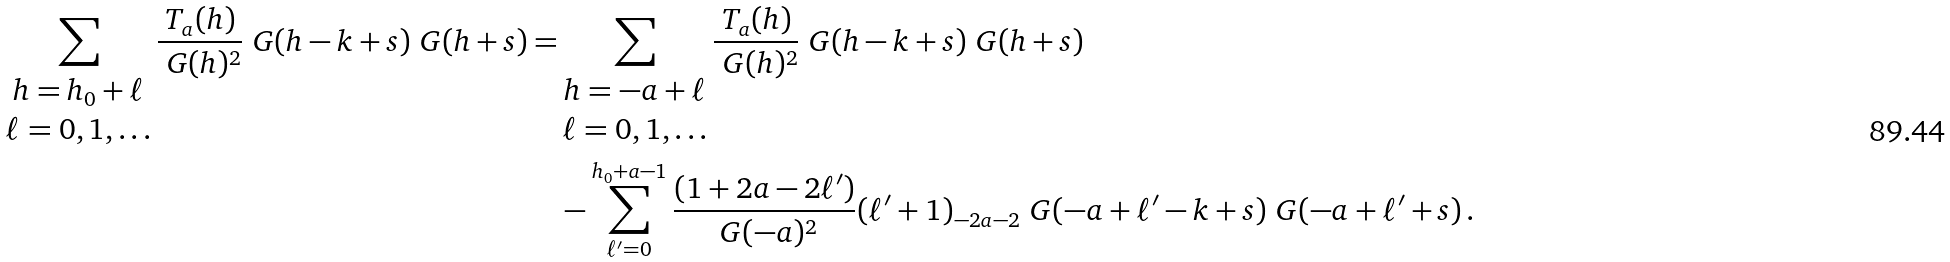Convert formula to latex. <formula><loc_0><loc_0><loc_500><loc_500>\sum _ { \begin{matrix} h = h _ { 0 } + \ell \\ \ell = 0 , 1 , \dots \end{matrix} } \frac { T _ { a } ( h ) } { \ G ( h ) ^ { 2 } } \ G ( h - k + s ) \ G ( h + s ) = & \sum _ { \begin{matrix} h = - a + \ell \\ \ell = 0 , 1 , \dots \end{matrix} } \frac { T _ { a } ( h ) } { \ G ( h ) ^ { 2 } } \ G ( h - k + s ) \ G ( h + s ) \\ & - \sum _ { \ell ^ { \prime } = 0 } ^ { h _ { 0 } + a - 1 } \frac { ( 1 + 2 a - 2 \ell ^ { \prime } ) } { \ G ( - a ) ^ { 2 } } ( \ell ^ { \prime } + 1 ) _ { - 2 a - 2 } \ G ( - a + \ell ^ { \prime } - k + s ) \ G ( - a + \ell ^ { \prime } + s ) \, .</formula> 